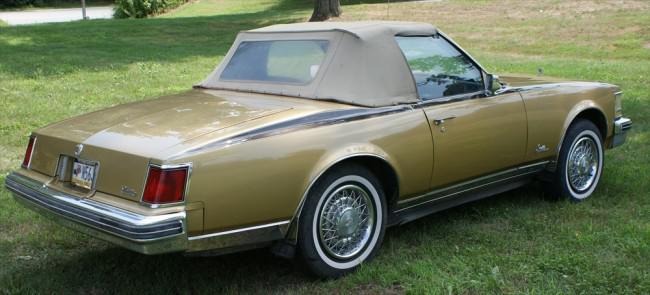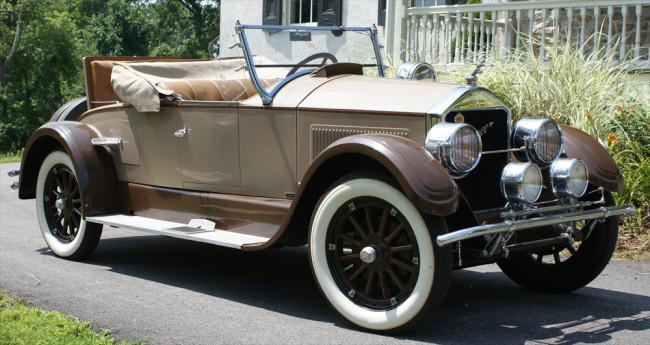The first image is the image on the left, the second image is the image on the right. For the images shown, is this caption "Both vehicles are Jeep Wranglers." true? Answer yes or no. No. The first image is the image on the left, the second image is the image on the right. Considering the images on both sides, is "there are two jeeps in the image pair facing each other" valid? Answer yes or no. No. 